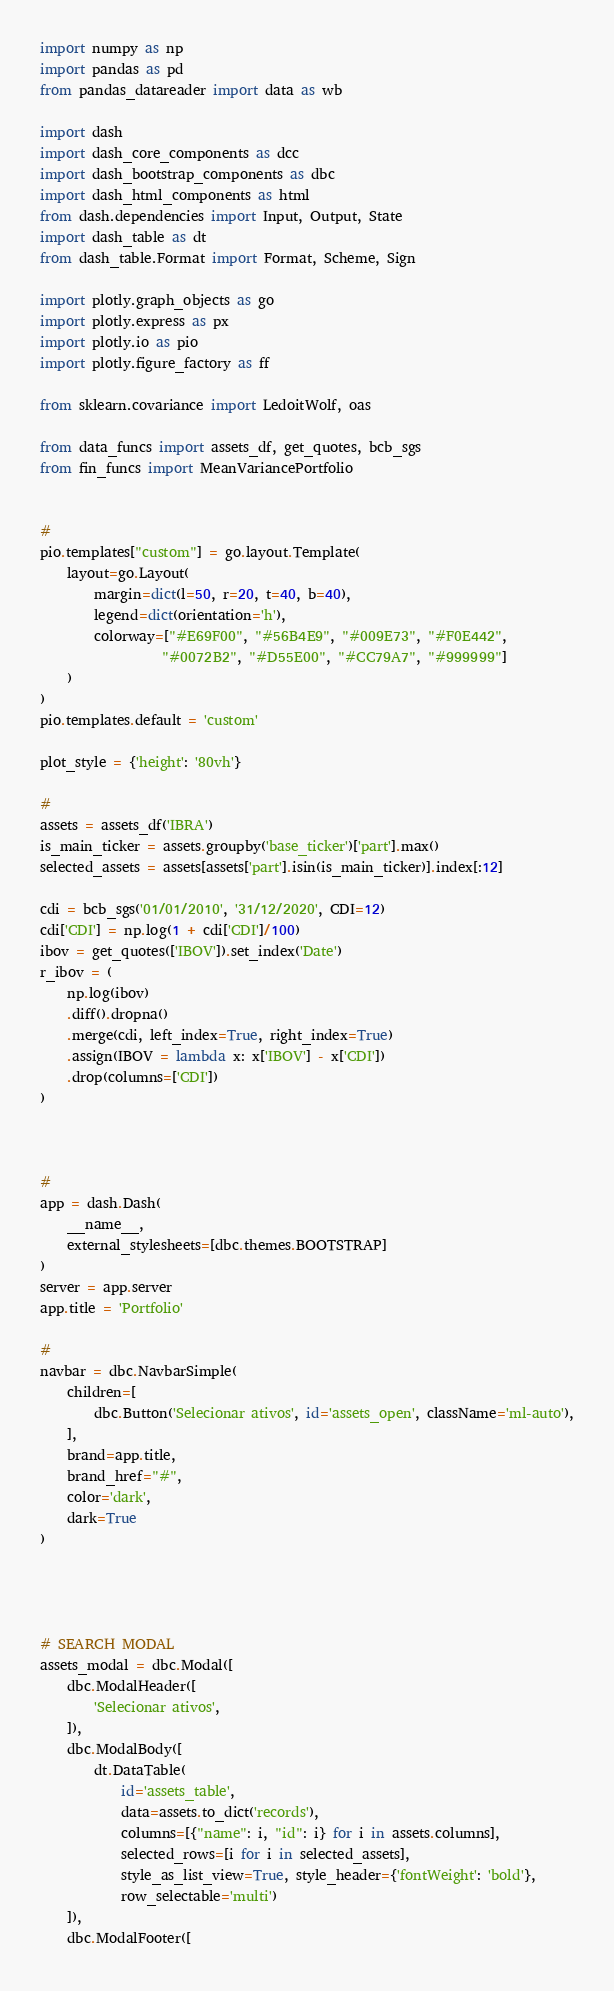Convert code to text. <code><loc_0><loc_0><loc_500><loc_500><_Python_>import numpy as np
import pandas as pd
from pandas_datareader import data as wb

import dash
import dash_core_components as dcc
import dash_bootstrap_components as dbc
import dash_html_components as html
from dash.dependencies import Input, Output, State
import dash_table as dt
from dash_table.Format import Format, Scheme, Sign

import plotly.graph_objects as go
import plotly.express as px
import plotly.io as pio
import plotly.figure_factory as ff

from sklearn.covariance import LedoitWolf, oas

from data_funcs import assets_df, get_quotes, bcb_sgs
from fin_funcs import MeanVariancePortfolio


#
pio.templates["custom"] = go.layout.Template(
    layout=go.Layout(
        margin=dict(l=50, r=20, t=40, b=40),
        legend=dict(orientation='h'),
        colorway=["#E69F00", "#56B4E9", "#009E73", "#F0E442", 
                  "#0072B2", "#D55E00", "#CC79A7", "#999999"]
    )
)
pio.templates.default = 'custom'

plot_style = {'height': '80vh'}

#
assets = assets_df('IBRA')
is_main_ticker = assets.groupby('base_ticker')['part'].max()
selected_assets = assets[assets['part'].isin(is_main_ticker)].index[:12]

cdi = bcb_sgs('01/01/2010', '31/12/2020', CDI=12)
cdi['CDI'] = np.log(1 + cdi['CDI']/100)
ibov = get_quotes(['IBOV']).set_index('Date')
r_ibov = (
    np.log(ibov)
    .diff().dropna()
    .merge(cdi, left_index=True, right_index=True)
    .assign(IBOV = lambda x: x['IBOV'] - x['CDI'])
    .drop(columns=['CDI'])
)



#
app = dash.Dash(
    __name__,
    external_stylesheets=[dbc.themes.BOOTSTRAP]
)
server = app.server
app.title = 'Portfolio'

#
navbar = dbc.NavbarSimple(
    children=[
        dbc.Button('Selecionar ativos', id='assets_open', className='ml-auto'),
    ],
    brand=app.title,
    brand_href="#",
    color='dark',
    dark=True
)




# SEARCH MODAL
assets_modal = dbc.Modal([
    dbc.ModalHeader([
        'Selecionar ativos',
    ]),
    dbc.ModalBody([
        dt.DataTable(
            id='assets_table',
            data=assets.to_dict('records'),
            columns=[{"name": i, "id": i} for i in assets.columns],
            selected_rows=[i for i in selected_assets],
            style_as_list_view=True, style_header={'fontWeight': 'bold'},
            row_selectable='multi')
    ]),
    dbc.ModalFooter([</code> 